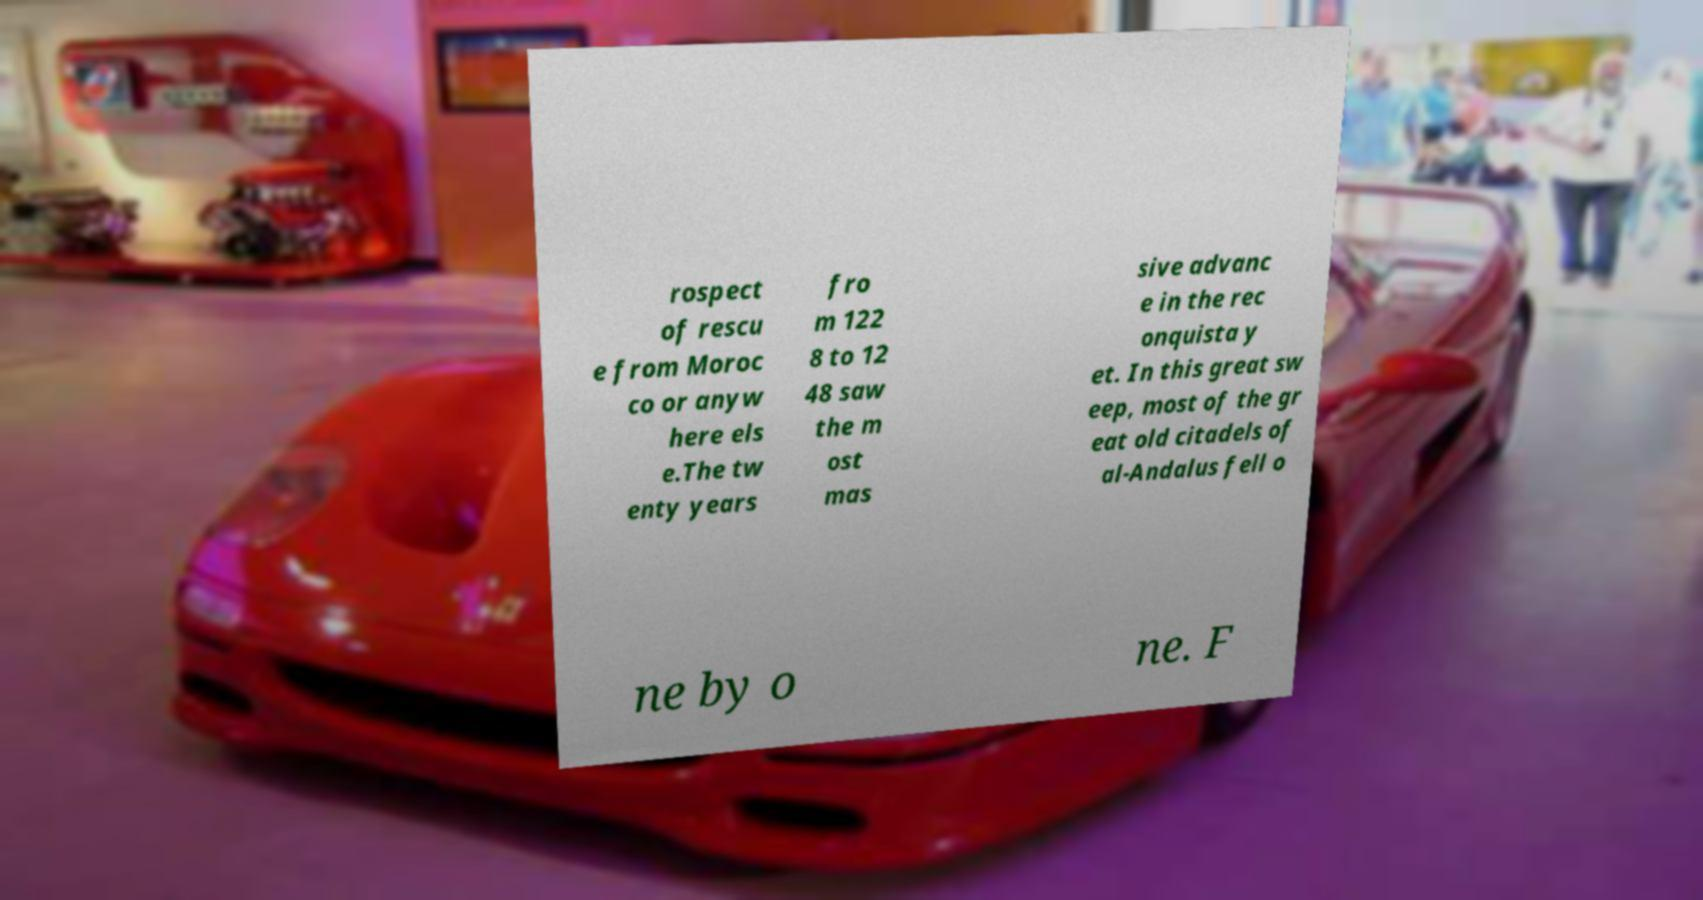I need the written content from this picture converted into text. Can you do that? rospect of rescu e from Moroc co or anyw here els e.The tw enty years fro m 122 8 to 12 48 saw the m ost mas sive advanc e in the rec onquista y et. In this great sw eep, most of the gr eat old citadels of al-Andalus fell o ne by o ne. F 